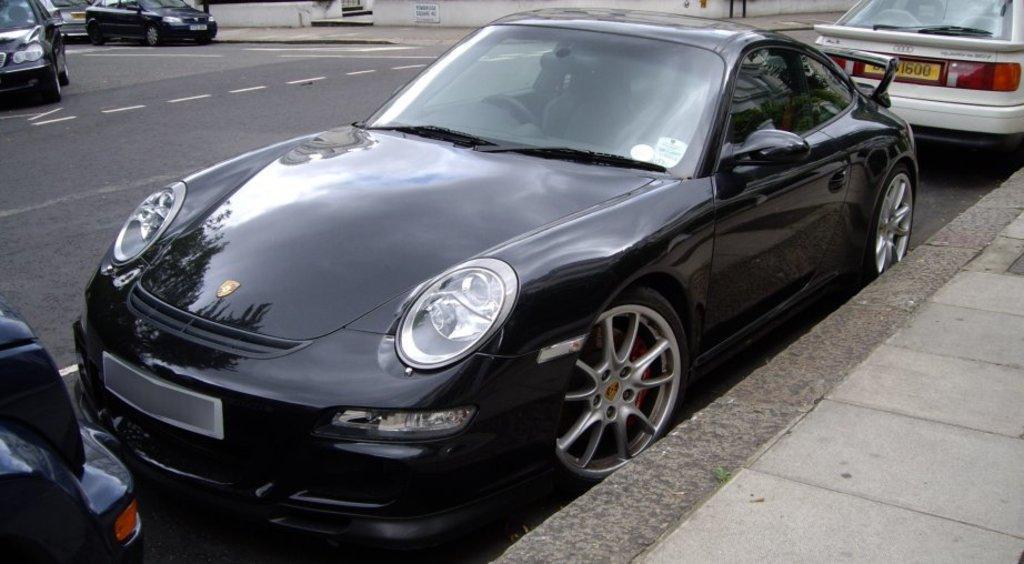In one or two sentences, can you explain what this image depicts? In the center of the image we can see a few vehicles on the road. On the right side of the image, there is a platform. In the background there is a wall and a few other objects. 